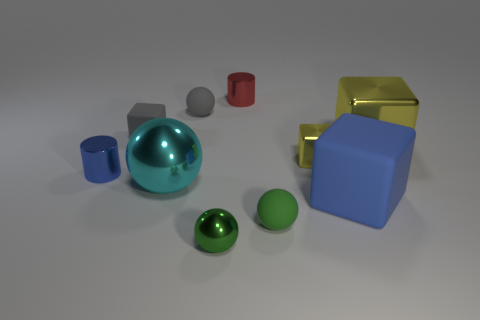Is the number of big metallic objects that are behind the large shiny sphere greater than the number of small blue shiny balls?
Provide a short and direct response. Yes. What number of metal things are both in front of the gray block and right of the tiny blue metallic thing?
Ensure brevity in your answer.  4. There is a small ball right of the small metal cylinder behind the small blue metal cylinder; what is its color?
Make the answer very short. Green. What number of matte objects are the same color as the tiny matte block?
Offer a terse response. 1. Is the color of the small metal cube the same as the small block that is left of the small yellow metallic thing?
Offer a terse response. No. Is the number of red metallic cubes less than the number of cyan objects?
Your answer should be compact. Yes. Is the number of large blocks that are behind the large cyan sphere greater than the number of tiny blue cylinders to the right of the tiny gray rubber cube?
Your answer should be very brief. Yes. Are the large blue thing and the big cyan thing made of the same material?
Make the answer very short. No. What number of gray cubes are to the left of the small metallic cylinder to the right of the large ball?
Your answer should be compact. 1. Does the rubber ball that is on the left side of the red cylinder have the same color as the tiny rubber block?
Provide a succinct answer. Yes. 